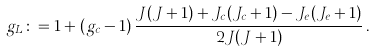Convert formula to latex. <formula><loc_0><loc_0><loc_500><loc_500>g _ { L } \colon = 1 + ( g _ { c } - 1 ) \, \frac { J ( J + 1 ) + J _ { c } ( J _ { c } + 1 ) - J _ { e } ( J _ { e } + 1 ) } { 2 J ( J + 1 ) } \, .</formula> 